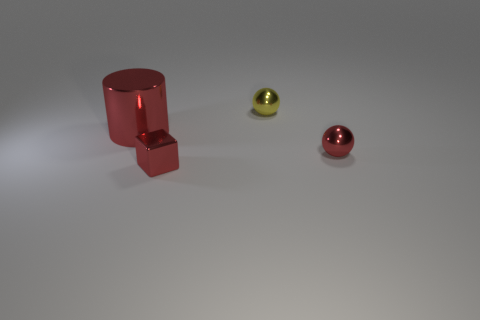Add 4 small red spheres. How many objects exist? 8 Subtract all cylinders. How many objects are left? 3 Add 1 cylinders. How many cylinders are left? 2 Add 4 blocks. How many blocks exist? 5 Subtract 1 yellow spheres. How many objects are left? 3 Subtract all big yellow rubber objects. Subtract all metallic cylinders. How many objects are left? 3 